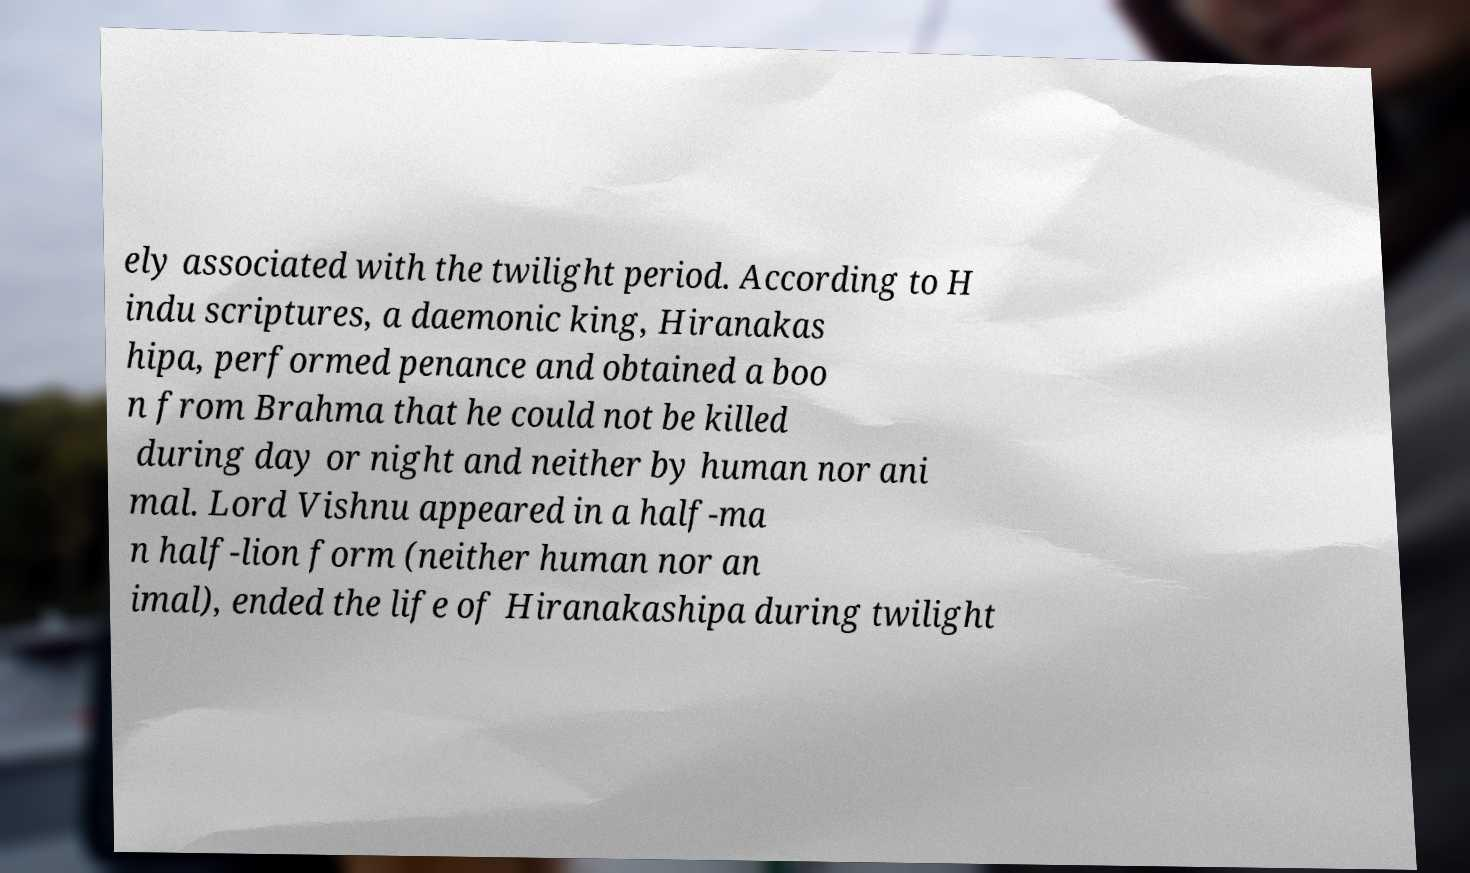Please read and relay the text visible in this image. What does it say? ely associated with the twilight period. According to H indu scriptures, a daemonic king, Hiranakas hipa, performed penance and obtained a boo n from Brahma that he could not be killed during day or night and neither by human nor ani mal. Lord Vishnu appeared in a half-ma n half-lion form (neither human nor an imal), ended the life of Hiranakashipa during twilight 